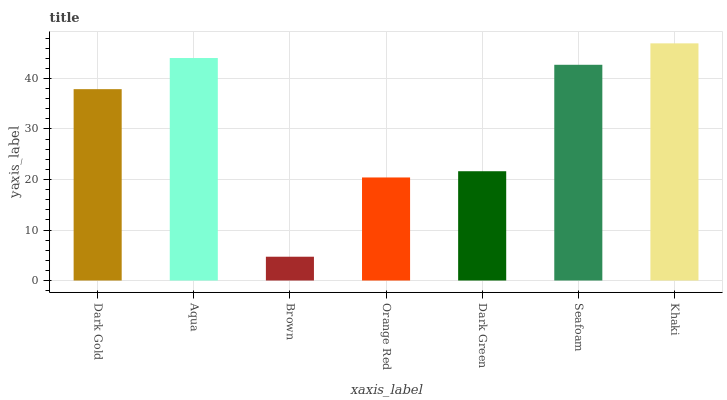Is Brown the minimum?
Answer yes or no. Yes. Is Khaki the maximum?
Answer yes or no. Yes. Is Aqua the minimum?
Answer yes or no. No. Is Aqua the maximum?
Answer yes or no. No. Is Aqua greater than Dark Gold?
Answer yes or no. Yes. Is Dark Gold less than Aqua?
Answer yes or no. Yes. Is Dark Gold greater than Aqua?
Answer yes or no. No. Is Aqua less than Dark Gold?
Answer yes or no. No. Is Dark Gold the high median?
Answer yes or no. Yes. Is Dark Gold the low median?
Answer yes or no. Yes. Is Dark Green the high median?
Answer yes or no. No. Is Orange Red the low median?
Answer yes or no. No. 